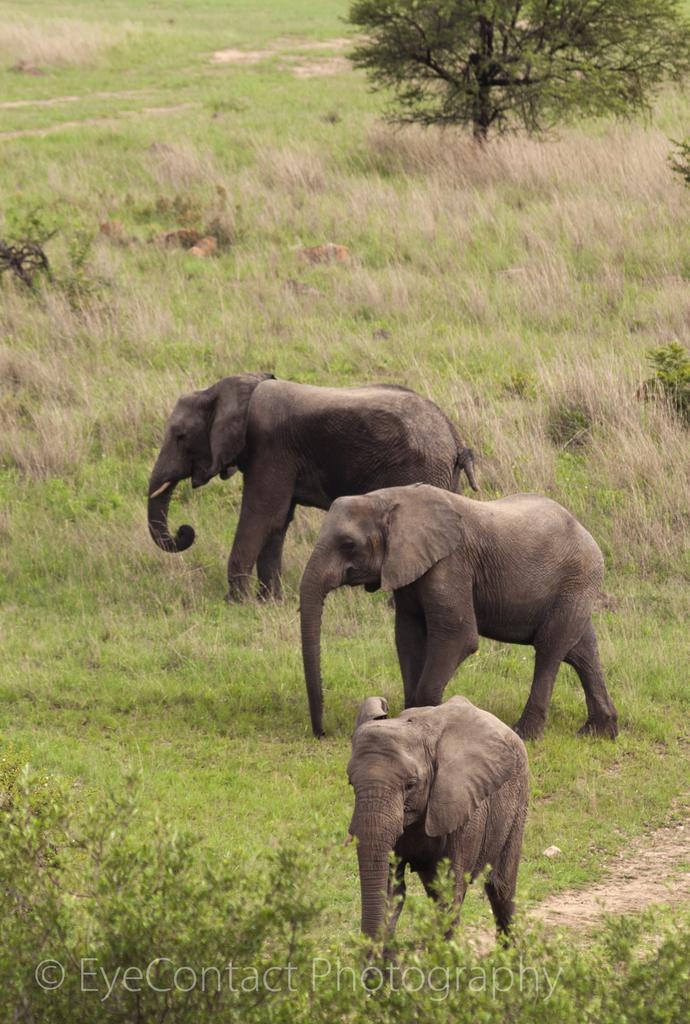Could you give a brief overview of what you see in this image? In this picture I can see three elephants are standing on the ground. In the background I can see grass, plants and trees. 